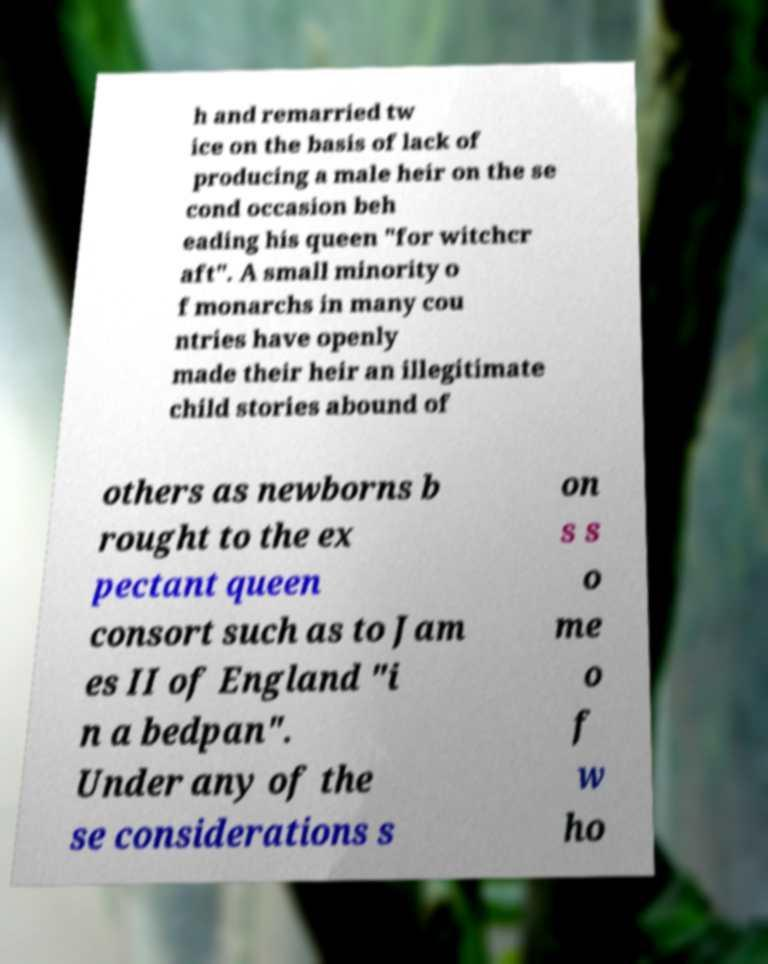Could you extract and type out the text from this image? h and remarried tw ice on the basis of lack of producing a male heir on the se cond occasion beh eading his queen "for witchcr aft". A small minority o f monarchs in many cou ntries have openly made their heir an illegitimate child stories abound of others as newborns b rought to the ex pectant queen consort such as to Jam es II of England "i n a bedpan". Under any of the se considerations s on s s o me o f w ho 